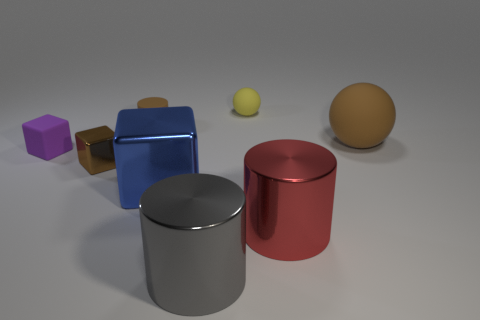The tiny brown object that is right of the tiny metallic thing has what shape?
Your response must be concise. Cylinder. How many large cyan rubber blocks are there?
Provide a succinct answer. 0. Are the large sphere and the tiny brown cylinder made of the same material?
Make the answer very short. Yes. Are there more big red things right of the gray cylinder than tiny yellow metallic spheres?
Ensure brevity in your answer.  Yes. How many objects are either cubes or things that are right of the blue metallic object?
Ensure brevity in your answer.  7. Is the number of tiny things to the left of the small ball greater than the number of brown shiny blocks that are in front of the purple thing?
Provide a succinct answer. Yes. What is the material of the large thing that is left of the big cylinder that is left of the sphere that is to the left of the brown sphere?
Offer a very short reply. Metal. There is a blue object that is made of the same material as the red thing; what is its shape?
Your response must be concise. Cube. Is there a small brown rubber thing in front of the small matte thing that is in front of the brown rubber sphere?
Your answer should be very brief. No. How big is the red metallic thing?
Give a very brief answer. Large. 